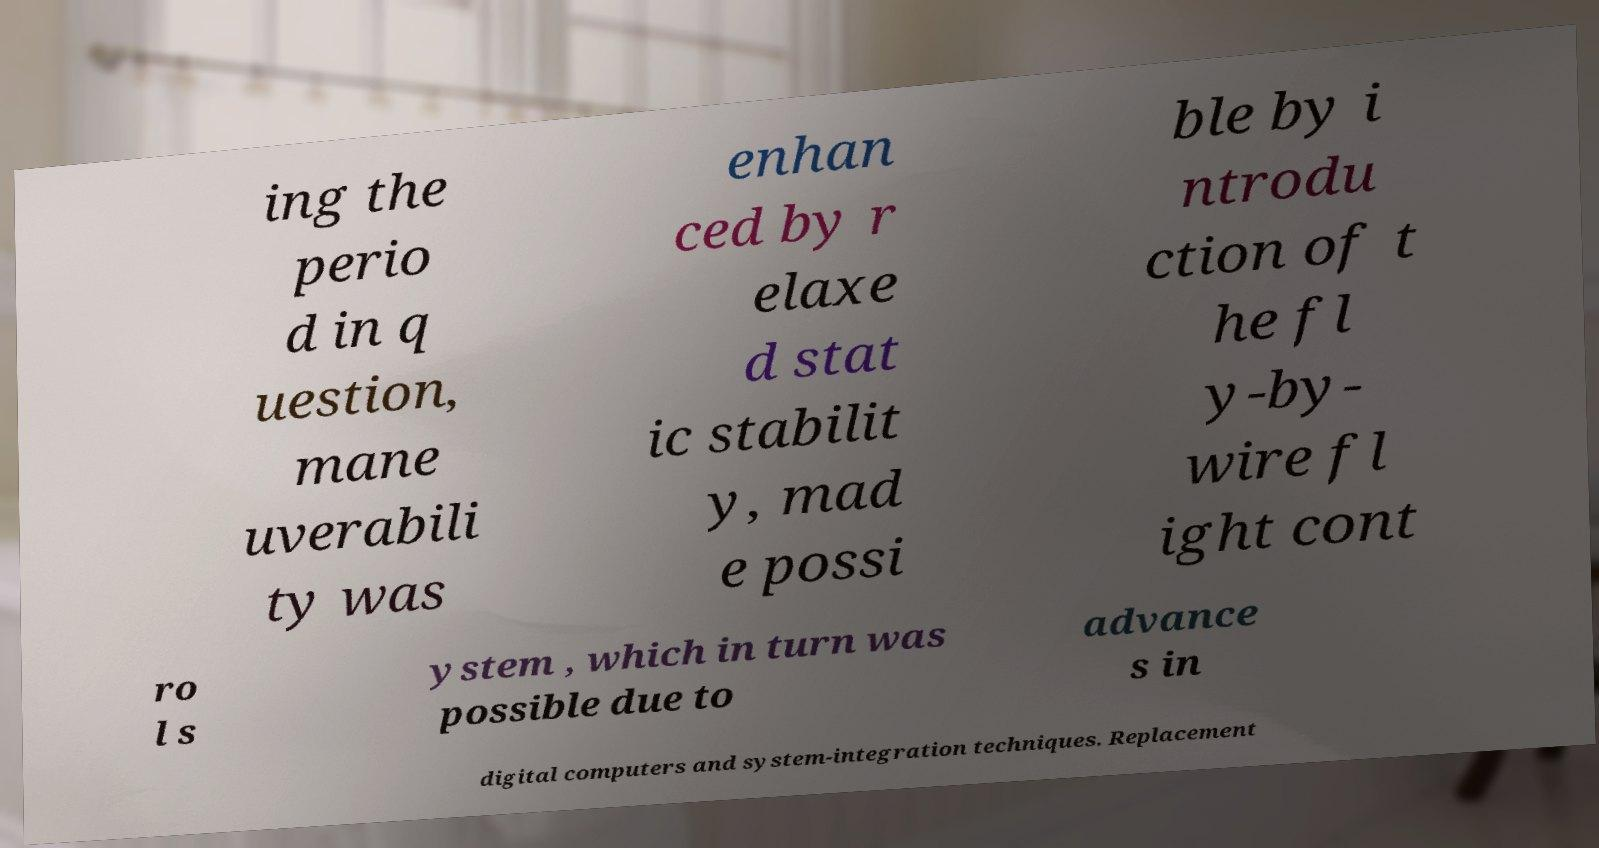There's text embedded in this image that I need extracted. Can you transcribe it verbatim? ing the perio d in q uestion, mane uverabili ty was enhan ced by r elaxe d stat ic stabilit y, mad e possi ble by i ntrodu ction of t he fl y-by- wire fl ight cont ro l s ystem , which in turn was possible due to advance s in digital computers and system-integration techniques. Replacement 